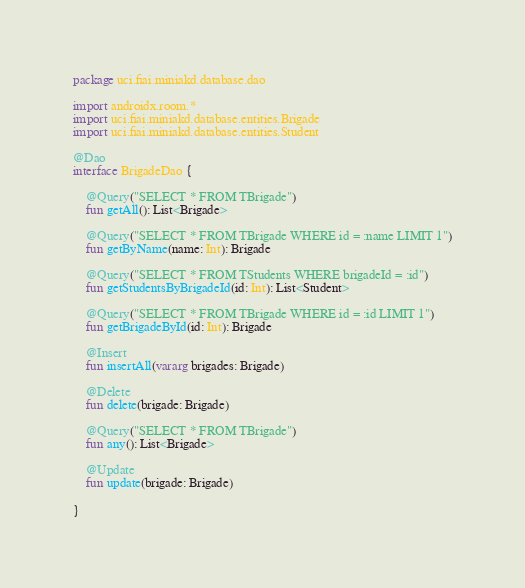<code> <loc_0><loc_0><loc_500><loc_500><_Kotlin_>package uci.fiai.miniakd.database.dao

import androidx.room.*
import uci.fiai.miniakd.database.entities.Brigade
import uci.fiai.miniakd.database.entities.Student

@Dao
interface BrigadeDao {

    @Query("SELECT * FROM TBrigade")
    fun getAll(): List<Brigade>

    @Query("SELECT * FROM TBrigade WHERE id = :name LIMIT 1")
    fun getByName(name: Int): Brigade

    @Query("SELECT * FROM TStudents WHERE brigadeId = :id")
    fun getStudentsByBrigadeId(id: Int): List<Student>

    @Query("SELECT * FROM TBrigade WHERE id = :id LIMIT 1")
    fun getBrigadeById(id: Int): Brigade

    @Insert
    fun insertAll(vararg brigades: Brigade)

    @Delete
    fun delete(brigade: Brigade)

    @Query("SELECT * FROM TBrigade")
    fun any(): List<Brigade>

    @Update
    fun update(brigade: Brigade)

}</code> 